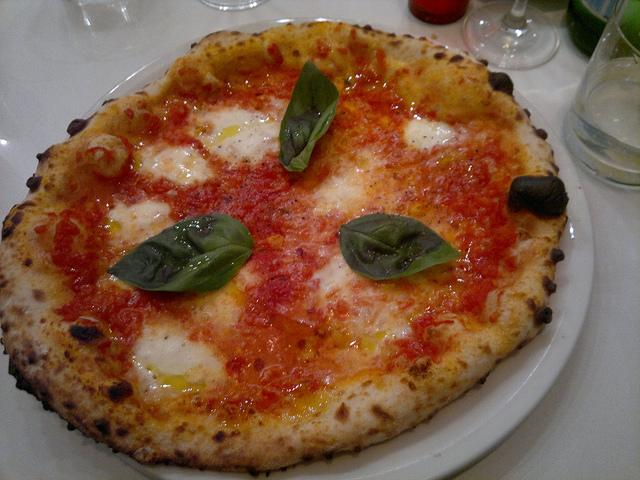Which one of these cheeses is rarely seen on this dish? Please explain your reasoning. american. American is usually not see as a cheese on italian pizza. 